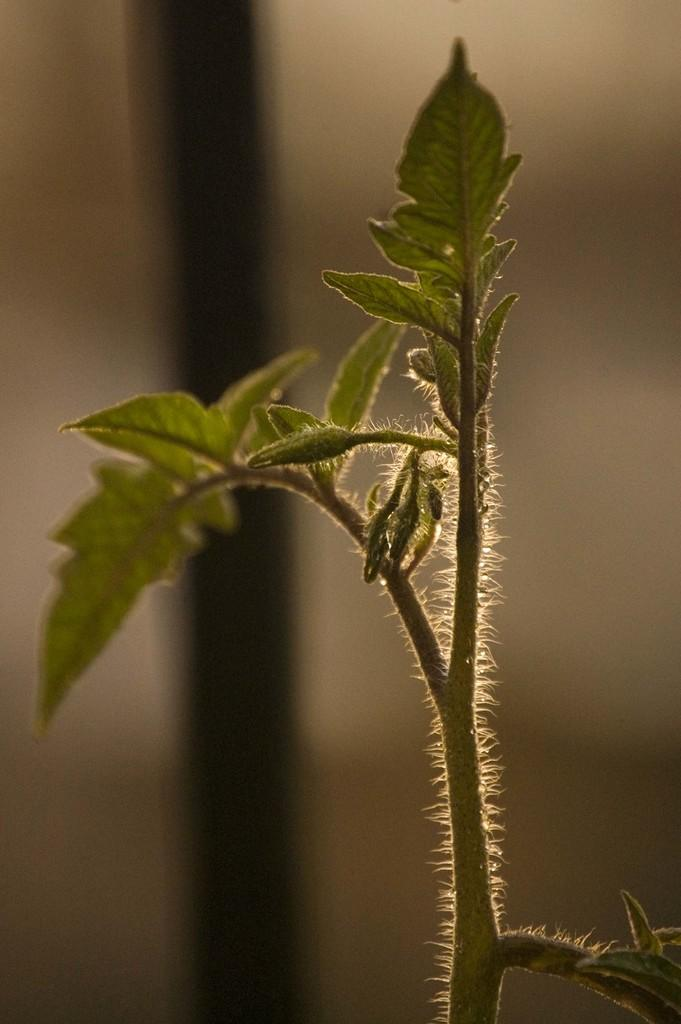What type of plant can be seen in the image? There is a green color plant in the image. What colors are present in the background of the image? The background of the image is in brown and black colors. What type of channel can be seen in the image? There is no channel present in the image; it features a green color plant and a brown and black background. How many knees are visible in the image? There are no knees visible in the image, as it only contains a plant and a background. 